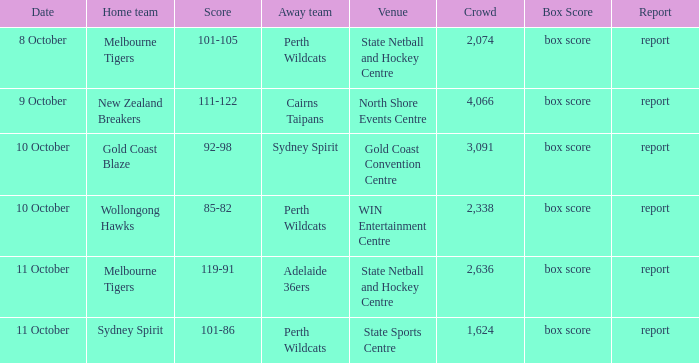What was the number of the crowd when the Wollongong Hawks were the home team? 2338.0. 